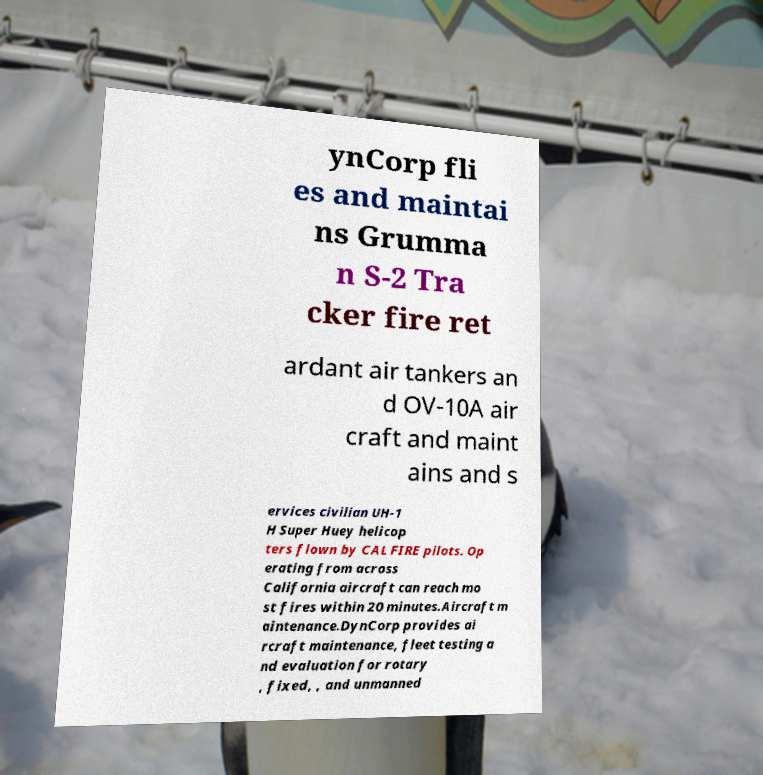There's text embedded in this image that I need extracted. Can you transcribe it verbatim? ynCorp fli es and maintai ns Grumma n S-2 Tra cker fire ret ardant air tankers an d OV-10A air craft and maint ains and s ervices civilian UH-1 H Super Huey helicop ters flown by CAL FIRE pilots. Op erating from across California aircraft can reach mo st fires within 20 minutes.Aircraft m aintenance.DynCorp provides ai rcraft maintenance, fleet testing a nd evaluation for rotary , fixed, , and unmanned 